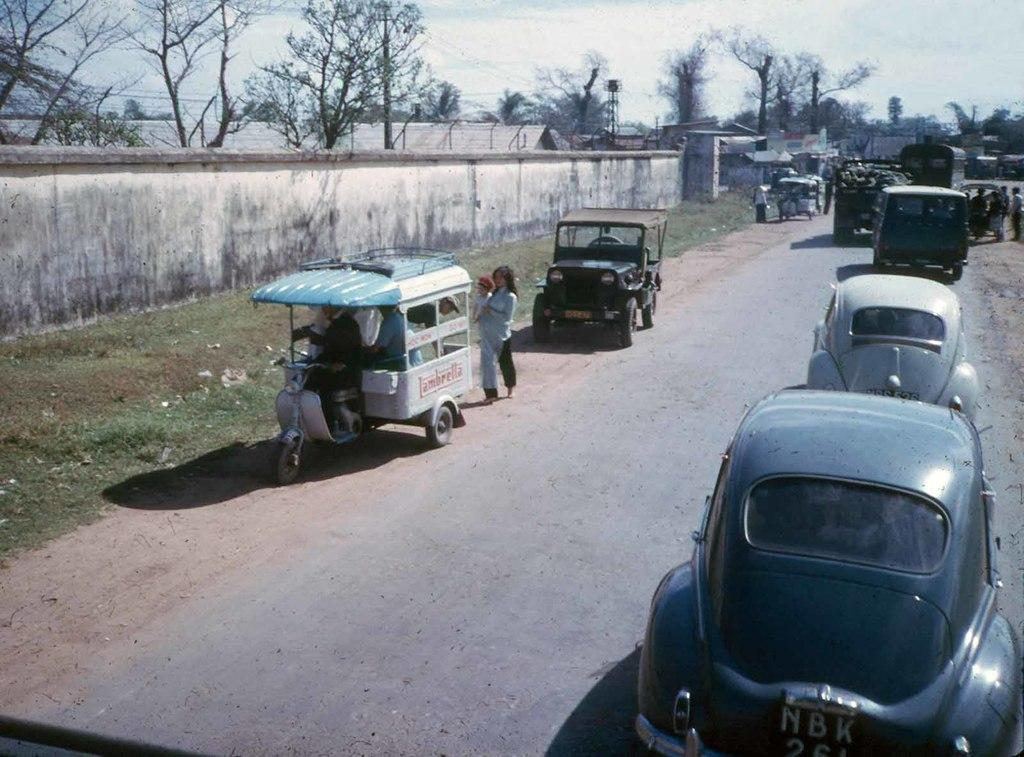What can be seen on the road in the image? There are vehicles on the road in the image. What are the people in the image doing? The people in the image are standing on the ground. What type of natural environment is visible in the background of the image? There are trees, grass, and the sky visible in the background of the image. What architectural feature can be seen in the background of the image? There is a fence in the background of the image. What other objects can be seen in the background of the image? There are other objects in the background of the image, but their specific details are not mentioned in the provided facts. What type of tin is being used to build the vehicles in the image? There is no mention of tin being used to build the vehicles in the image. What role does zinc play in the image? There is no mention of zinc in the image, so its role cannot be determined. 